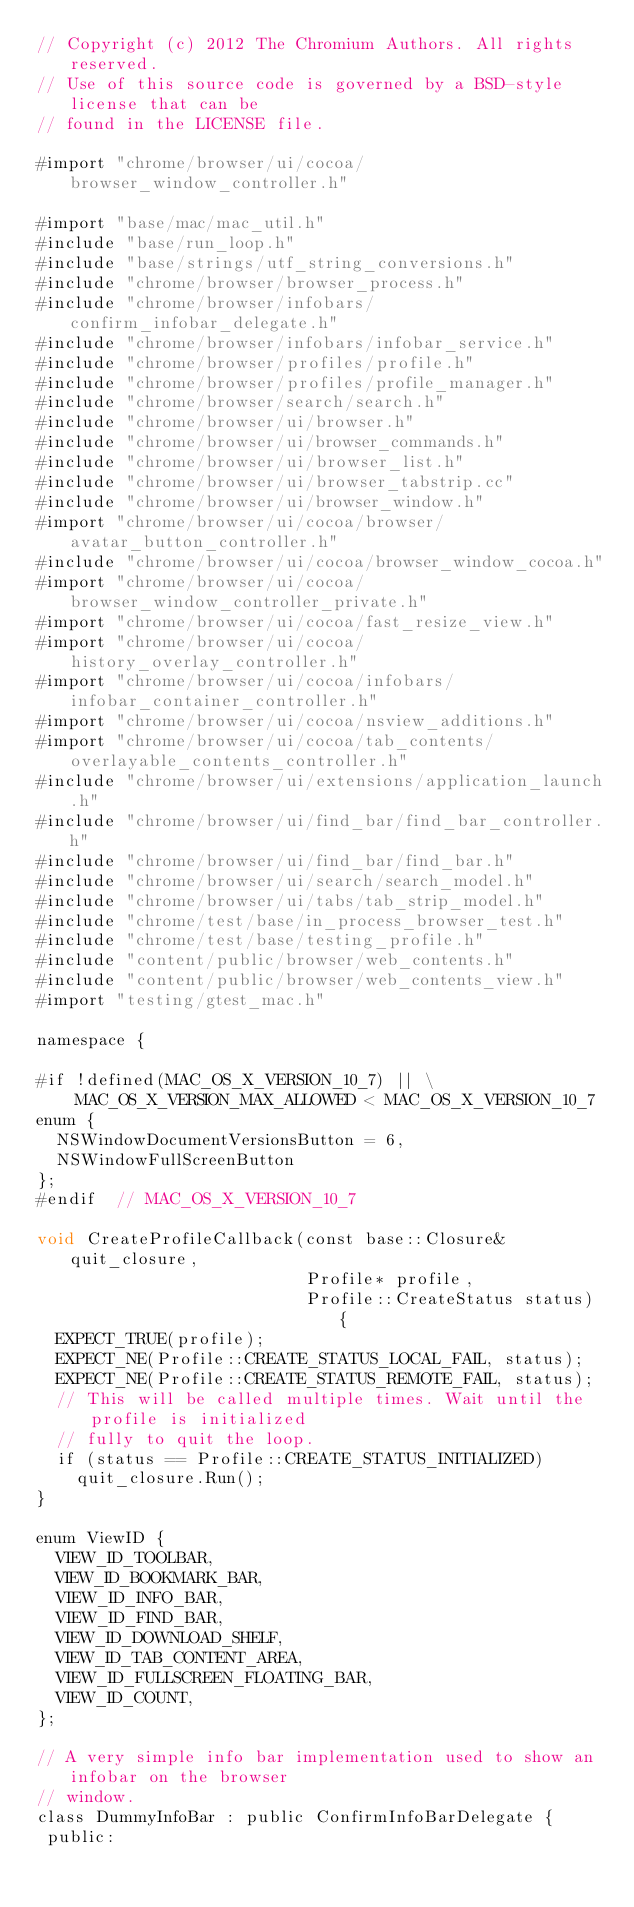<code> <loc_0><loc_0><loc_500><loc_500><_ObjectiveC_>// Copyright (c) 2012 The Chromium Authors. All rights reserved.
// Use of this source code is governed by a BSD-style license that can be
// found in the LICENSE file.

#import "chrome/browser/ui/cocoa/browser_window_controller.h"

#import "base/mac/mac_util.h"
#include "base/run_loop.h"
#include "base/strings/utf_string_conversions.h"
#include "chrome/browser/browser_process.h"
#include "chrome/browser/infobars/confirm_infobar_delegate.h"
#include "chrome/browser/infobars/infobar_service.h"
#include "chrome/browser/profiles/profile.h"
#include "chrome/browser/profiles/profile_manager.h"
#include "chrome/browser/search/search.h"
#include "chrome/browser/ui/browser.h"
#include "chrome/browser/ui/browser_commands.h"
#include "chrome/browser/ui/browser_list.h"
#include "chrome/browser/ui/browser_tabstrip.cc"
#include "chrome/browser/ui/browser_window.h"
#import "chrome/browser/ui/cocoa/browser/avatar_button_controller.h"
#include "chrome/browser/ui/cocoa/browser_window_cocoa.h"
#import "chrome/browser/ui/cocoa/browser_window_controller_private.h"
#import "chrome/browser/ui/cocoa/fast_resize_view.h"
#import "chrome/browser/ui/cocoa/history_overlay_controller.h"
#import "chrome/browser/ui/cocoa/infobars/infobar_container_controller.h"
#import "chrome/browser/ui/cocoa/nsview_additions.h"
#import "chrome/browser/ui/cocoa/tab_contents/overlayable_contents_controller.h"
#include "chrome/browser/ui/extensions/application_launch.h"
#include "chrome/browser/ui/find_bar/find_bar_controller.h"
#include "chrome/browser/ui/find_bar/find_bar.h"
#include "chrome/browser/ui/search/search_model.h"
#include "chrome/browser/ui/tabs/tab_strip_model.h"
#include "chrome/test/base/in_process_browser_test.h"
#include "chrome/test/base/testing_profile.h"
#include "content/public/browser/web_contents.h"
#include "content/public/browser/web_contents_view.h"
#import "testing/gtest_mac.h"

namespace {

#if !defined(MAC_OS_X_VERSION_10_7) || \
    MAC_OS_X_VERSION_MAX_ALLOWED < MAC_OS_X_VERSION_10_7
enum {
  NSWindowDocumentVersionsButton = 6,
  NSWindowFullScreenButton
};
#endif  // MAC_OS_X_VERSION_10_7

void CreateProfileCallback(const base::Closure& quit_closure,
                           Profile* profile,
                           Profile::CreateStatus status) {
  EXPECT_TRUE(profile);
  EXPECT_NE(Profile::CREATE_STATUS_LOCAL_FAIL, status);
  EXPECT_NE(Profile::CREATE_STATUS_REMOTE_FAIL, status);
  // This will be called multiple times. Wait until the profile is initialized
  // fully to quit the loop.
  if (status == Profile::CREATE_STATUS_INITIALIZED)
    quit_closure.Run();
}

enum ViewID {
  VIEW_ID_TOOLBAR,
  VIEW_ID_BOOKMARK_BAR,
  VIEW_ID_INFO_BAR,
  VIEW_ID_FIND_BAR,
  VIEW_ID_DOWNLOAD_SHELF,
  VIEW_ID_TAB_CONTENT_AREA,
  VIEW_ID_FULLSCREEN_FLOATING_BAR,
  VIEW_ID_COUNT,
};

// A very simple info bar implementation used to show an infobar on the browser
// window.
class DummyInfoBar : public ConfirmInfoBarDelegate {
 public:</code> 